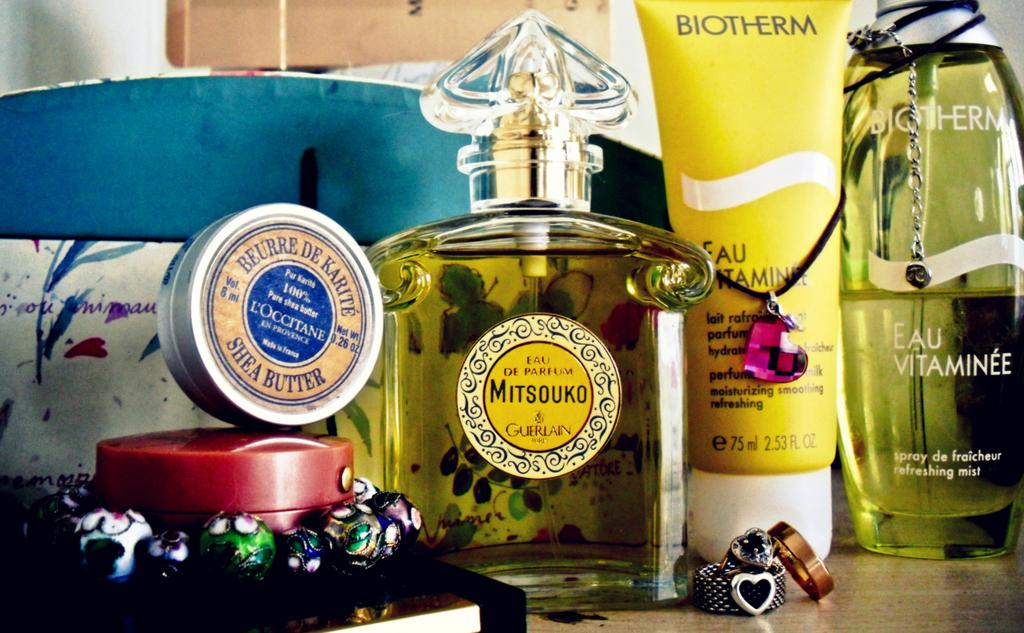<image>
Describe the image concisely. large bottle of Mitsouko next to a yellow bottle of Biotherm. 